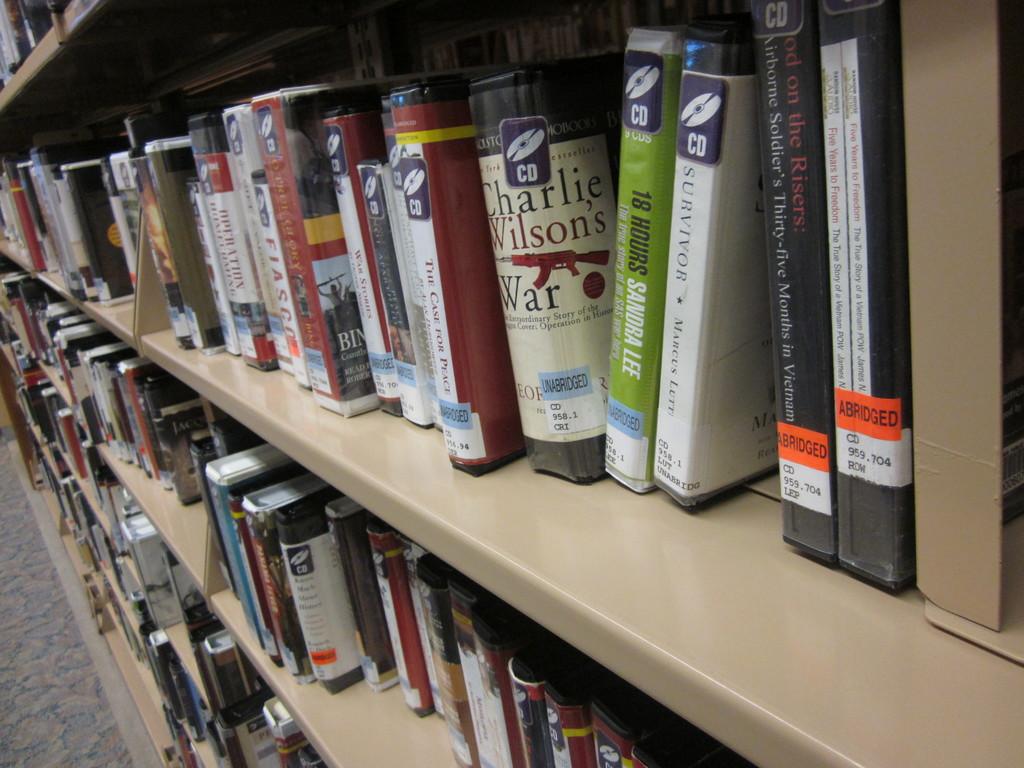What time of books are marked with the orange sticker?
Provide a short and direct response. Abridged. Charlie wilson's what?
Make the answer very short. War. 